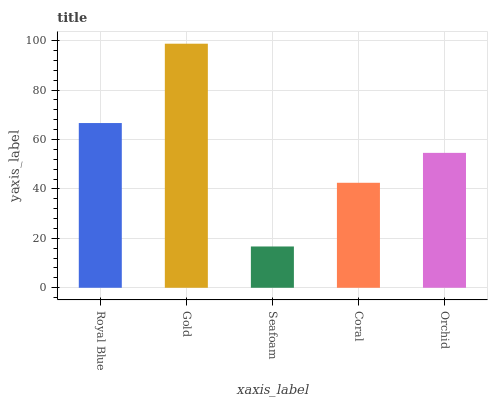Is Seafoam the minimum?
Answer yes or no. Yes. Is Gold the maximum?
Answer yes or no. Yes. Is Gold the minimum?
Answer yes or no. No. Is Seafoam the maximum?
Answer yes or no. No. Is Gold greater than Seafoam?
Answer yes or no. Yes. Is Seafoam less than Gold?
Answer yes or no. Yes. Is Seafoam greater than Gold?
Answer yes or no. No. Is Gold less than Seafoam?
Answer yes or no. No. Is Orchid the high median?
Answer yes or no. Yes. Is Orchid the low median?
Answer yes or no. Yes. Is Gold the high median?
Answer yes or no. No. Is Royal Blue the low median?
Answer yes or no. No. 